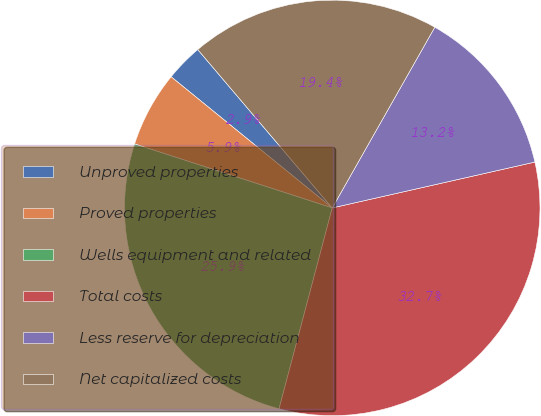<chart> <loc_0><loc_0><loc_500><loc_500><pie_chart><fcel>Unproved properties<fcel>Proved properties<fcel>Wells equipment and related<fcel>Total costs<fcel>Less reserve for depreciation<fcel>Net capitalized costs<nl><fcel>2.92%<fcel>5.89%<fcel>25.86%<fcel>32.66%<fcel>13.24%<fcel>19.42%<nl></chart> 